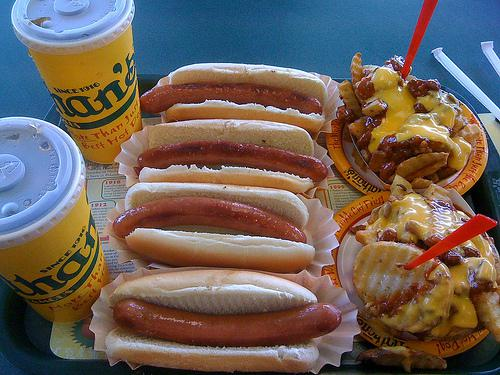Question: where is this taken?
Choices:
A. Chair.
B. Table.
C. Bench.
D. Counter.
Answer with the letter. Answer: B Question: what are they eating?
Choices:
A. Chili cheese fries and hot dogs.
B. Slices of pizza.
C. Hamburgers and fries with ketchup.
D. Gyros and chips.
Answer with the letter. Answer: A Question: where can you get this?
Choices:
A. Wendy's.
B. Arby's.
C. White Castle.
D. Nathan's.
Answer with the letter. Answer: D 